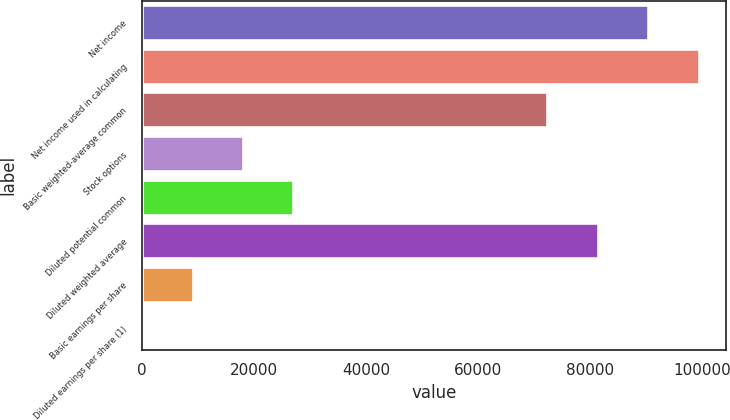<chart> <loc_0><loc_0><loc_500><loc_500><bar_chart><fcel>Net income<fcel>Net income used in calculating<fcel>Basic weighted-average common<fcel>Stock options<fcel>Diluted potential common<fcel>Diluted weighted average<fcel>Basic earnings per share<fcel>Diluted earnings per share (1)<nl><fcel>90281<fcel>99267.9<fcel>72307<fcel>17975.1<fcel>26962.1<fcel>81294<fcel>8988.14<fcel>1.16<nl></chart> 